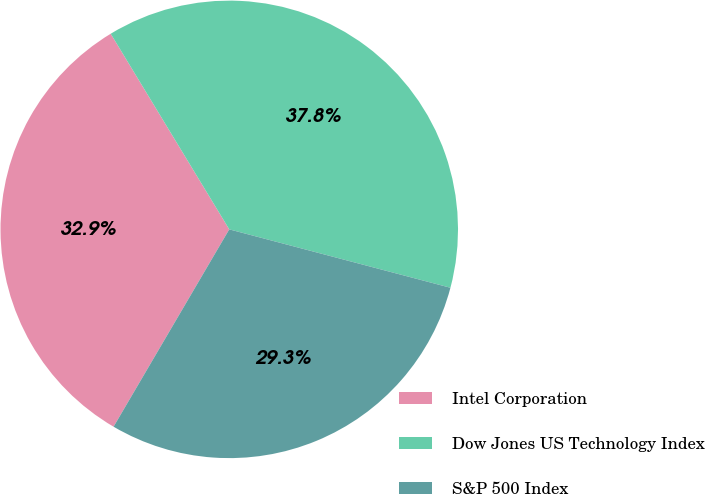Convert chart. <chart><loc_0><loc_0><loc_500><loc_500><pie_chart><fcel>Intel Corporation<fcel>Dow Jones US Technology Index<fcel>S&P 500 Index<nl><fcel>32.89%<fcel>37.78%<fcel>29.33%<nl></chart> 